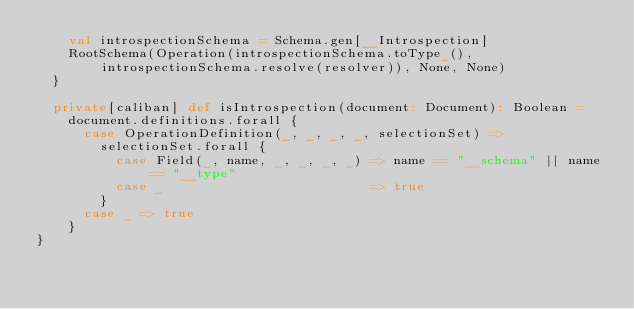Convert code to text. <code><loc_0><loc_0><loc_500><loc_500><_Scala_>    val introspectionSchema = Schema.gen[__Introspection]
    RootSchema(Operation(introspectionSchema.toType_(), introspectionSchema.resolve(resolver)), None, None)
  }

  private[caliban] def isIntrospection(document: Document): Boolean =
    document.definitions.forall {
      case OperationDefinition(_, _, _, _, selectionSet) =>
        selectionSet.forall {
          case Field(_, name, _, _, _, _) => name == "__schema" || name == "__type"
          case _                          => true
        }
      case _ => true
    }
}
</code> 